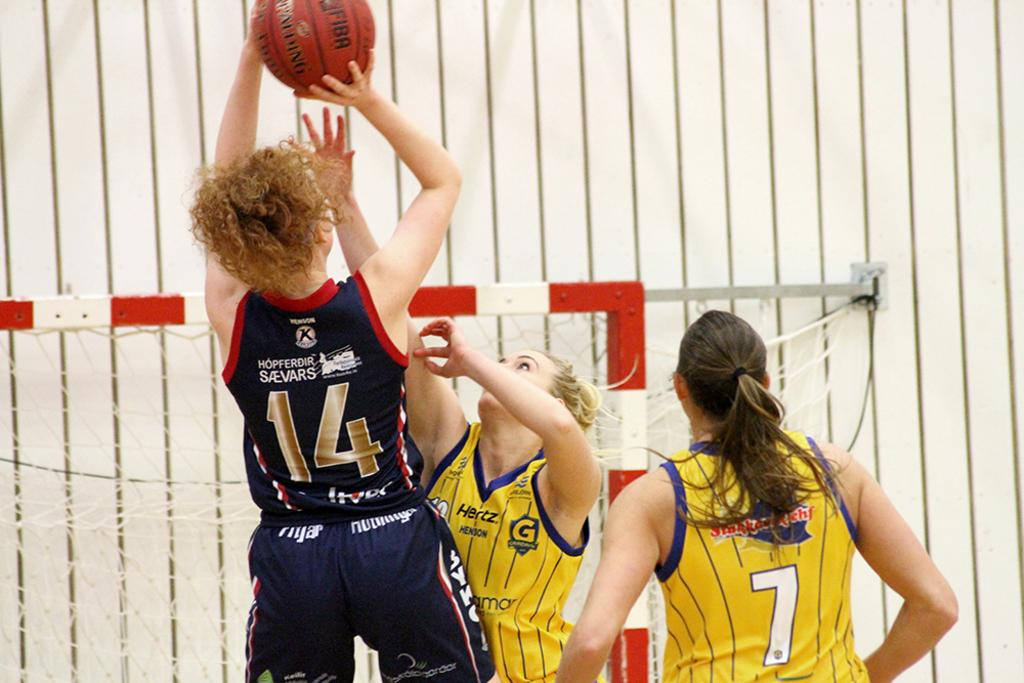<image>
Present a compact description of the photo's key features. Player number 14 shoots a basketball over the outstretched hand of a defender. 